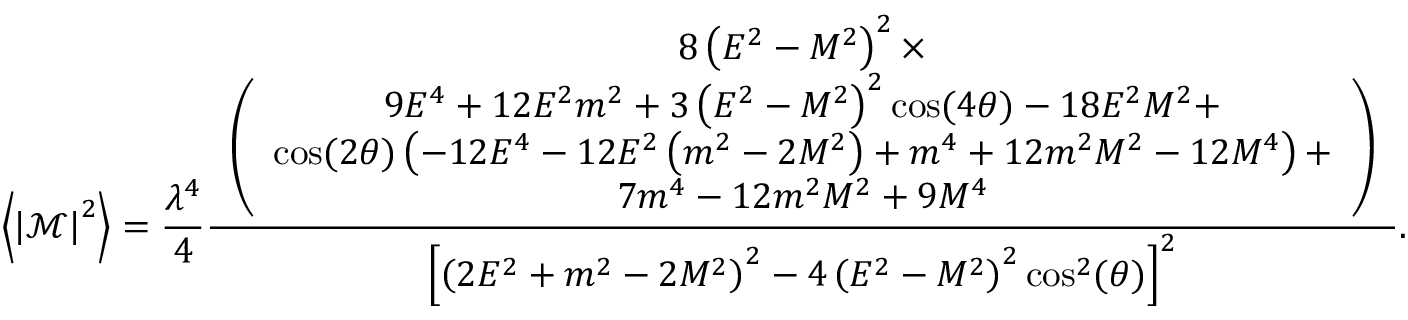<formula> <loc_0><loc_0><loc_500><loc_500>\left \langle \left | \mathcal { M } \right | ^ { 2 } \right \rangle = \frac { \lambda ^ { 4 } } { 4 } \frac { \begin{array} { c } { 8 \left ( E ^ { 2 } - M ^ { 2 } \right ) ^ { 2 } \times } \\ { \left ( \begin{array} { c } { 9 E ^ { 4 } + 1 2 E ^ { 2 } m ^ { 2 } + 3 \left ( E ^ { 2 } - M ^ { 2 } \right ) ^ { 2 } \cos ( 4 \theta ) - 1 8 E ^ { 2 } M ^ { 2 } + } \\ { \cos ( 2 \theta ) \left ( - 1 2 E ^ { 4 } - 1 2 E ^ { 2 } \left ( m ^ { 2 } - 2 M ^ { 2 } \right ) + m ^ { 4 } + 1 2 m ^ { 2 } M ^ { 2 } - 1 2 M ^ { 4 } \right ) + } \\ { 7 m ^ { 4 } - 1 2 m ^ { 2 } M ^ { 2 } + 9 M ^ { 4 } } \end{array} \right ) } \end{array} } { \left [ \left ( 2 E ^ { 2 } + m ^ { 2 } - 2 M ^ { 2 } \right ) ^ { 2 } - 4 \left ( E ^ { 2 } - M ^ { 2 } \right ) ^ { 2 } \cos ^ { 2 } ( \theta ) \right ] ^ { 2 } } .</formula> 